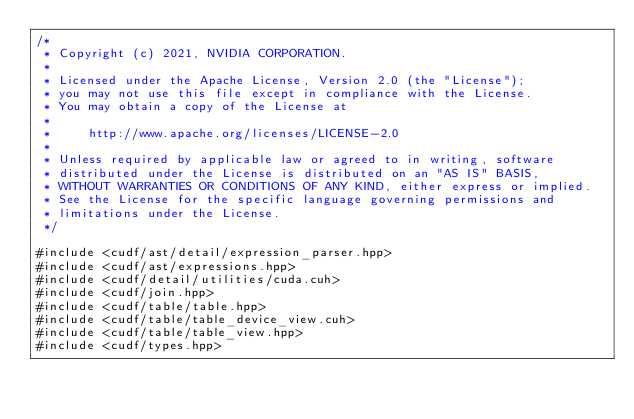Convert code to text. <code><loc_0><loc_0><loc_500><loc_500><_Cuda_>/*
 * Copyright (c) 2021, NVIDIA CORPORATION.
 *
 * Licensed under the Apache License, Version 2.0 (the "License");
 * you may not use this file except in compliance with the License.
 * You may obtain a copy of the License at
 *
 *     http://www.apache.org/licenses/LICENSE-2.0
 *
 * Unless required by applicable law or agreed to in writing, software
 * distributed under the License is distributed on an "AS IS" BASIS,
 * WITHOUT WARRANTIES OR CONDITIONS OF ANY KIND, either express or implied.
 * See the License for the specific language governing permissions and
 * limitations under the License.
 */

#include <cudf/ast/detail/expression_parser.hpp>
#include <cudf/ast/expressions.hpp>
#include <cudf/detail/utilities/cuda.cuh>
#include <cudf/join.hpp>
#include <cudf/table/table.hpp>
#include <cudf/table/table_device_view.cuh>
#include <cudf/table/table_view.hpp>
#include <cudf/types.hpp></code> 